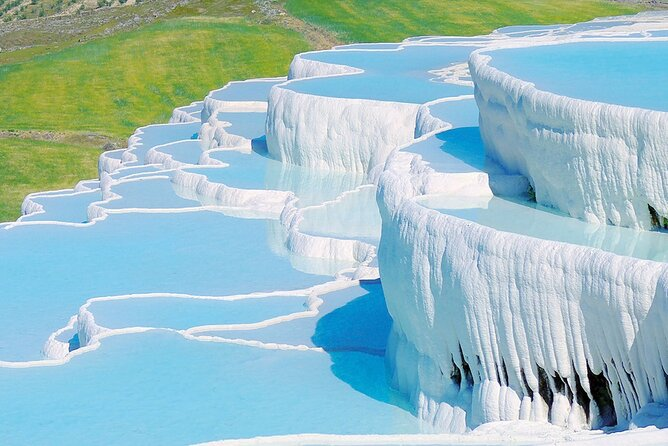What's happening in the scene? This captivating image showcases Pamukkale, a natural wonder in Turkey renowned for its spectacular white travertine terraces and mineral-rich thermal waters. The vibrant terraces consist of calcium carbonate deposits left by the flowing waters, which have carved the breathtaking landscape over millennia. The scene, captured from an elevated viewpoint, allows us to observe the serene blue pools gracefully descending through the multi-level terraced formations. The image also subtly captures the confluence of nature and historical allure, as Pamukkale has been a sought-after thermal spa since classical antiquity. 